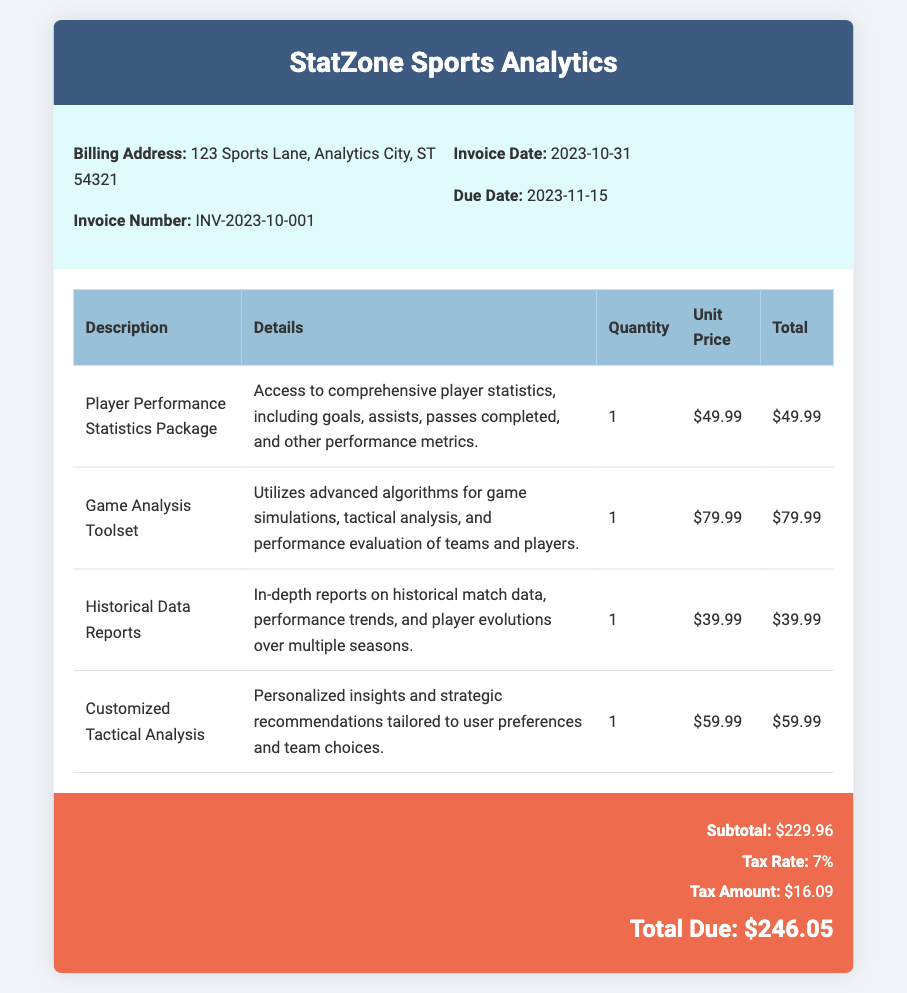What is the invoice number? The invoice number is specifically listed in the document under the billing details.
Answer: INV-2023-10-001 What is the total due amount? The total due amount is calculated including subtotal and tax, which is presented in the summary section.
Answer: $246.05 What is the tax amount? The tax amount is stated in the summary and is calculated based on the subtotal and tax rate.
Answer: $16.09 When is the due date for payment? The due date is provided in the invoice details section and indicates when the payment is expected.
Answer: 2023-11-15 How many services are listed in the invoice? The number of services can be counted from the table presented in the document under services.
Answer: 4 What is included in the Player Performance Statistics Package? A description of the service outlines the specifics of what is included in the package.
Answer: Access to comprehensive player statistics What is the unit price for the Game Analysis Toolset? The unit price is clearly indicated next to the description of the service in the services table.
Answer: $79.99 What percentage is the tax rate? The tax rate is specifically noted in the summary section of the document.
Answer: 7% What type of analysis does the Customized Tactical Analysis provide? The type of analysis is described in the services table, indicating the focus of this service.
Answer: Personalized insights and strategic recommendations 